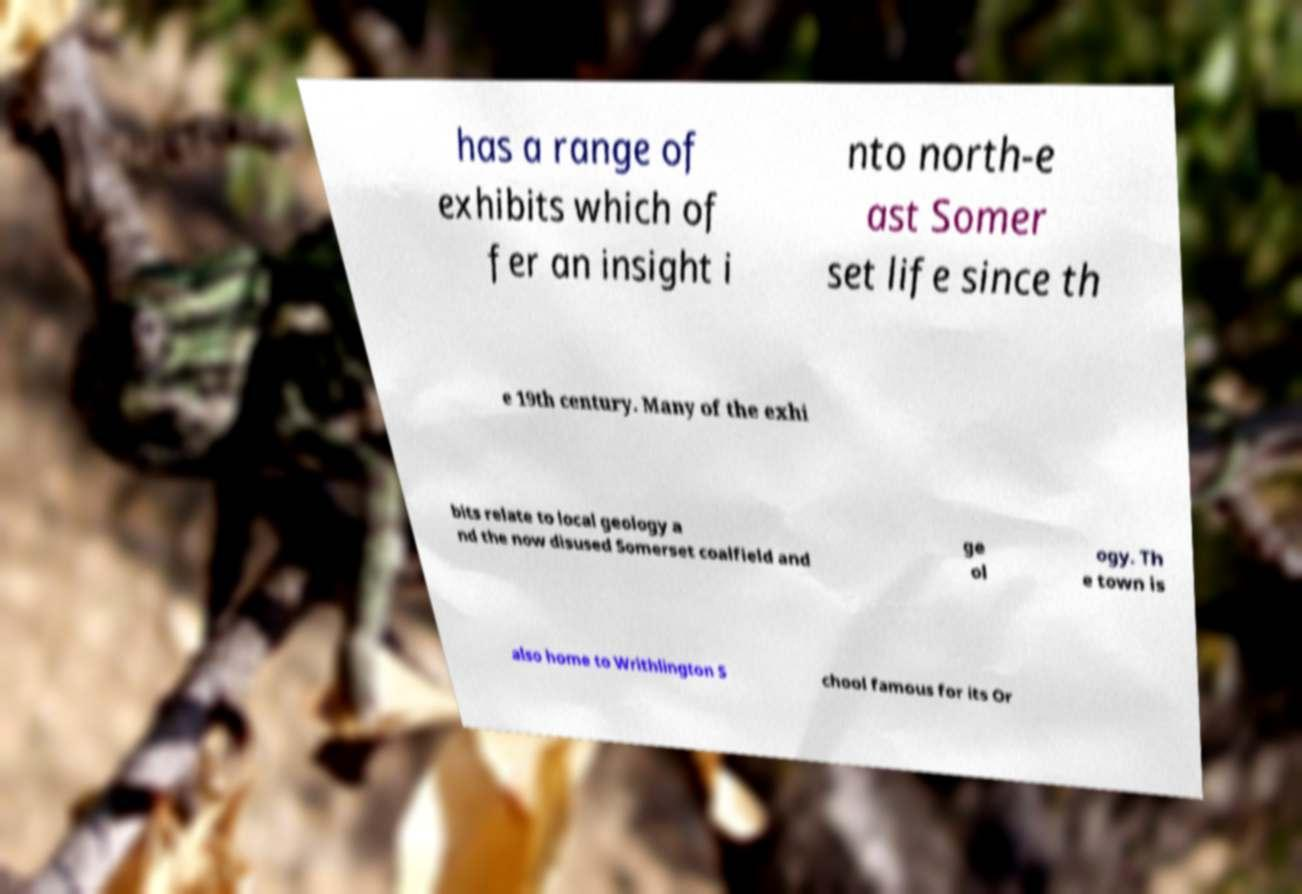Can you accurately transcribe the text from the provided image for me? has a range of exhibits which of fer an insight i nto north-e ast Somer set life since th e 19th century. Many of the exhi bits relate to local geology a nd the now disused Somerset coalfield and ge ol ogy. Th e town is also home to Writhlington S chool famous for its Or 